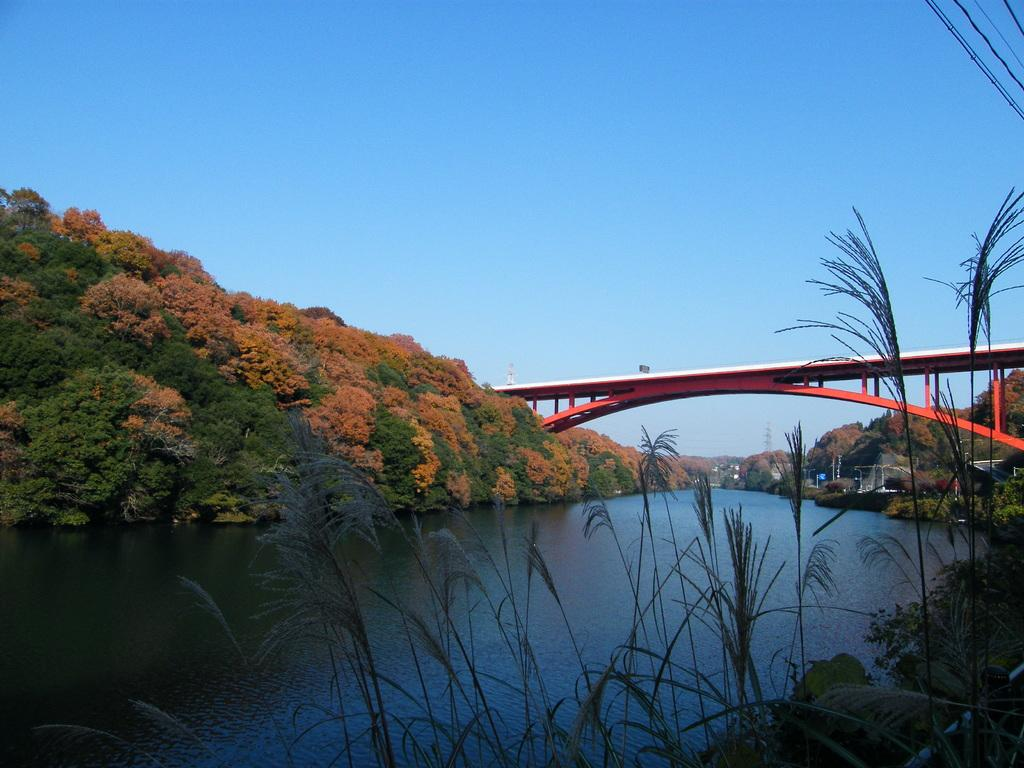What body of water is present in the image? There is a river in the image. How is the river crossed in the image? There is a bridge over the river in the image. What type of vegetation is present on either side of the river? There are plants and trees on either side of the river in the image. What can be seen in the background of the image? The sky is visible in the background of the image. What direction is the river being pulled in the image? The river is not being pulled in any direction in the image; it is a static body of water. 